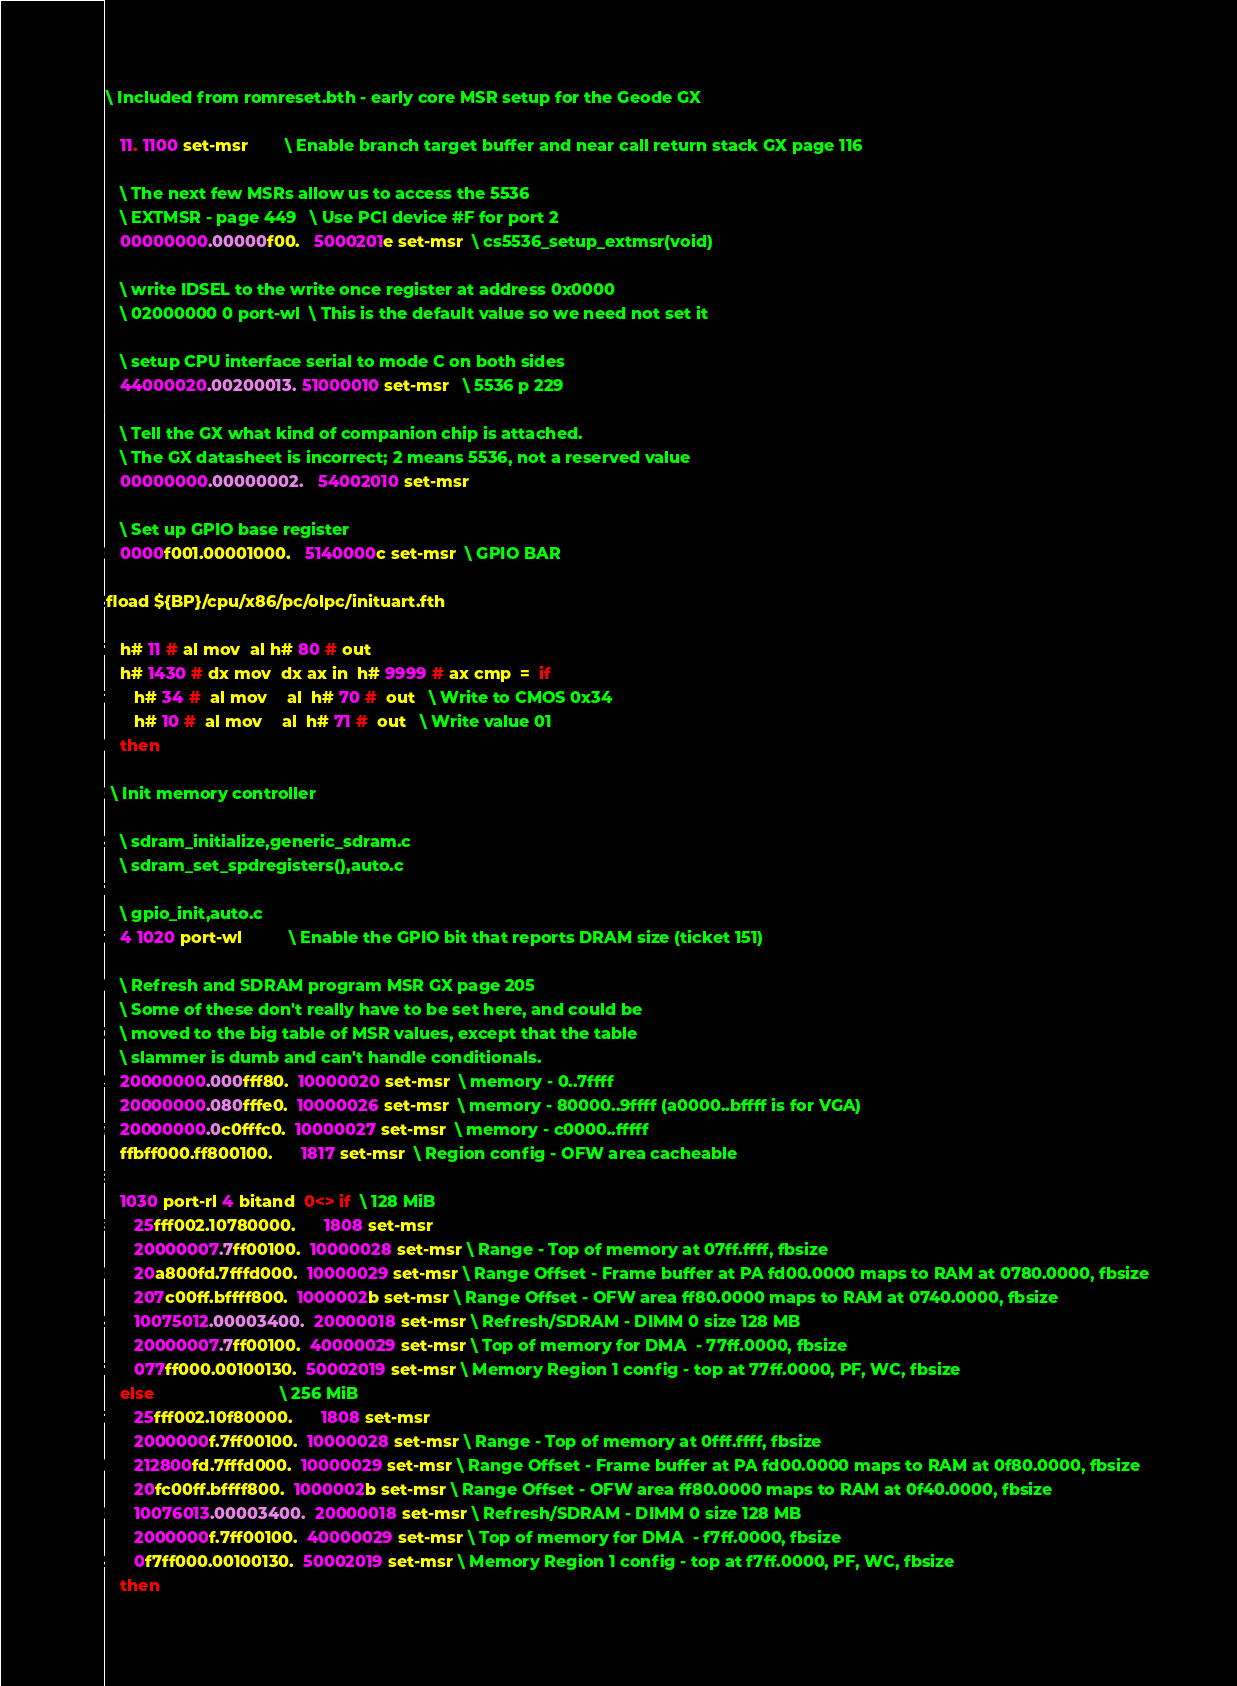<code> <loc_0><loc_0><loc_500><loc_500><_Forth_>\ Included from romreset.bth - early core MSR setup for the Geode GX

   11. 1100 set-msr        \ Enable branch target buffer and near call return stack GX page 116

   \ The next few MSRs allow us to access the 5536
   \ EXTMSR - page 449   \ Use PCI device #F for port 2
   00000000.00000f00.   5000201e set-msr  \ cs5536_setup_extmsr(void)

   \ write IDSEL to the write once register at address 0x0000
   \ 02000000 0 port-wl  \ This is the default value so we need not set it

   \ setup CPU interface serial to mode C on both sides
   44000020.00200013. 51000010 set-msr   \ 5536 p 229

   \ Tell the GX what kind of companion chip is attached.
   \ The GX datasheet is incorrect; 2 means 5536, not a reserved value
   00000000.00000002.   54002010 set-msr

   \ Set up GPIO base register
   0000f001.00001000.   5140000c set-msr  \ GPIO BAR

fload ${BP}/cpu/x86/pc/olpc/inituart.fth

   h# 11 # al mov  al h# 80 # out
   h# 1430 # dx mov  dx ax in  h# 9999 # ax cmp  =  if
      h# 34 #  al mov    al  h# 70 #  out   \ Write to CMOS 0x34
      h# 10 #  al mov    al  h# 71 #  out   \ Write value 01
   then

 \ Init memory controller

   \ sdram_initialize,generic_sdram.c
   \ sdram_set_spdregisters(),auto.c
 
   \ gpio_init,auto.c
   4 1020 port-wl          \ Enable the GPIO bit that reports DRAM size (ticket 151)

   \ Refresh and SDRAM program MSR GX page 205
   \ Some of these don't really have to be set here, and could be
   \ moved to the big table of MSR values, except that the table
   \ slammer is dumb and can't handle conditionals.
   20000000.000fff80.  10000020 set-msr  \ memory - 0..7ffff
   20000000.080fffe0.  10000026 set-msr  \ memory - 80000..9ffff (a0000..bffff is for VGA)
   20000000.0c0fffc0.  10000027 set-msr  \ memory - c0000..fffff
   ffbff000.ff800100.      1817 set-msr  \ Region config - OFW area cacheable

   1030 port-rl 4 bitand  0<> if  \ 128 MiB
      25fff002.10780000.      1808 set-msr
      20000007.7ff00100.  10000028 set-msr \ Range - Top of memory at 07ff.ffff, fbsize
      20a800fd.7fffd000.  10000029 set-msr \ Range Offset - Frame buffer at PA fd00.0000 maps to RAM at 0780.0000, fbsize
      207c00ff.bffff800.  1000002b set-msr \ Range Offset - OFW area ff80.0000 maps to RAM at 0740.0000, fbsize
      10075012.00003400.  20000018 set-msr \ Refresh/SDRAM - DIMM 0 size 128 MB
      20000007.7ff00100.  40000029 set-msr \ Top of memory for DMA  - 77ff.0000, fbsize
      077ff000.00100130.  50002019 set-msr \ Memory Region 1 config - top at 77ff.0000, PF, WC, fbsize
   else                           \ 256 MiB
      25fff002.10f80000.      1808 set-msr
      2000000f.7ff00100.  10000028 set-msr \ Range - Top of memory at 0fff.ffff, fbsize
      212800fd.7fffd000.  10000029 set-msr \ Range Offset - Frame buffer at PA fd00.0000 maps to RAM at 0f80.0000, fbsize
      20fc00ff.bffff800.  1000002b set-msr \ Range Offset - OFW area ff80.0000 maps to RAM at 0f40.0000, fbsize
      10076013.00003400.  20000018 set-msr \ Refresh/SDRAM - DIMM 0 size 128 MB
      2000000f.7ff00100.  40000029 set-msr \ Top of memory for DMA  - f7ff.0000, fbsize
      0f7ff000.00100130.  50002019 set-msr \ Memory Region 1 config - top at f7ff.0000, PF, WC, fbsize
   then
</code> 